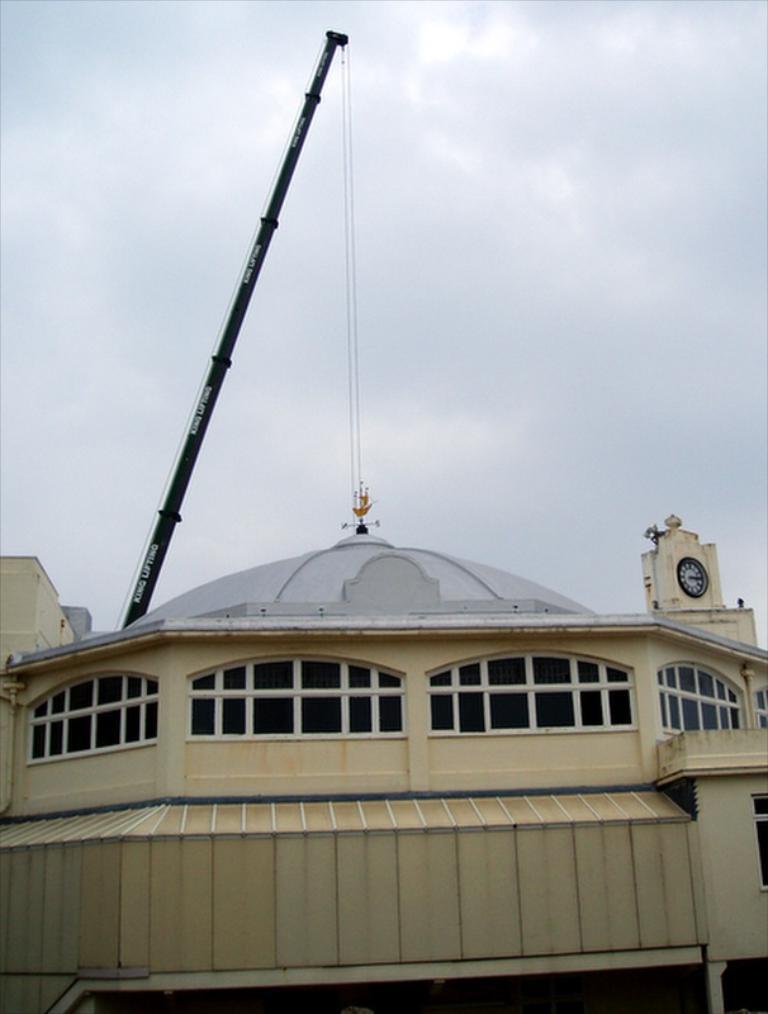Describe this image in one or two sentences. In this image we can see building, clock tower, construction crane and sky with clouds in the background. 